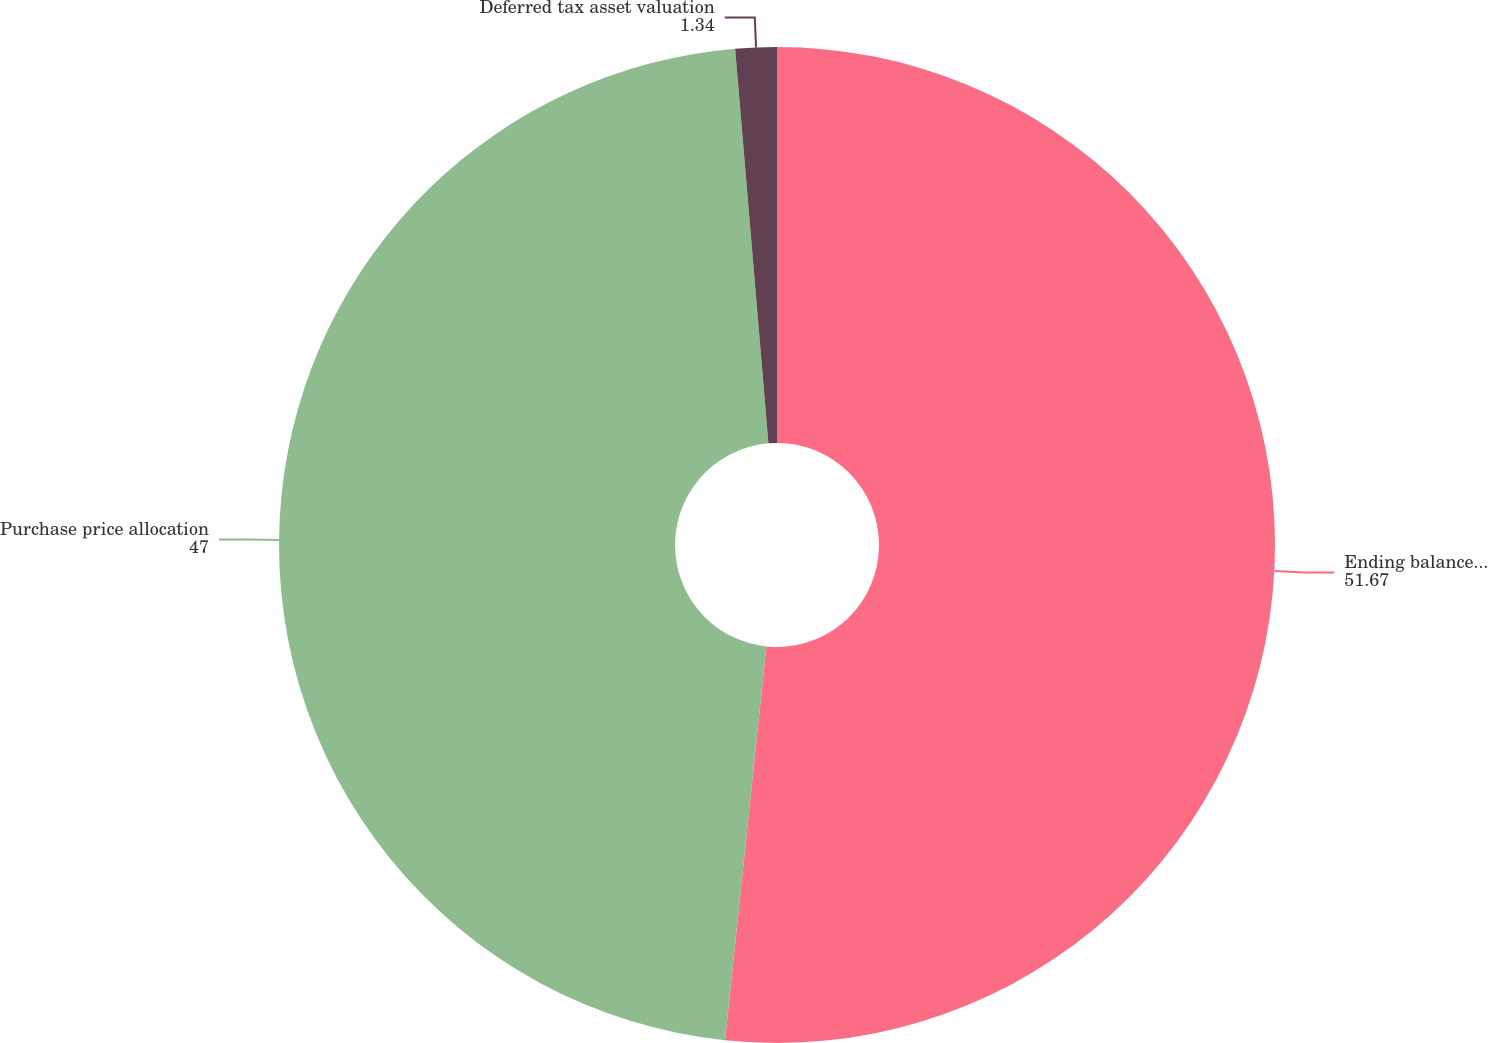Convert chart. <chart><loc_0><loc_0><loc_500><loc_500><pie_chart><fcel>Ending balance December 31<fcel>Purchase price allocation<fcel>Deferred tax asset valuation<nl><fcel>51.67%<fcel>47.0%<fcel>1.34%<nl></chart> 